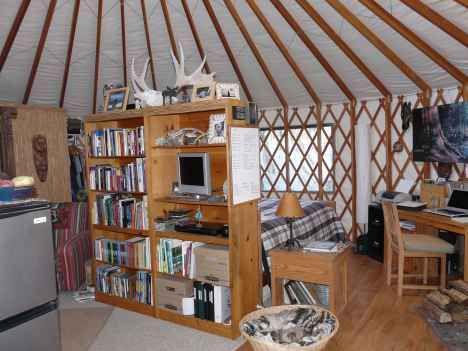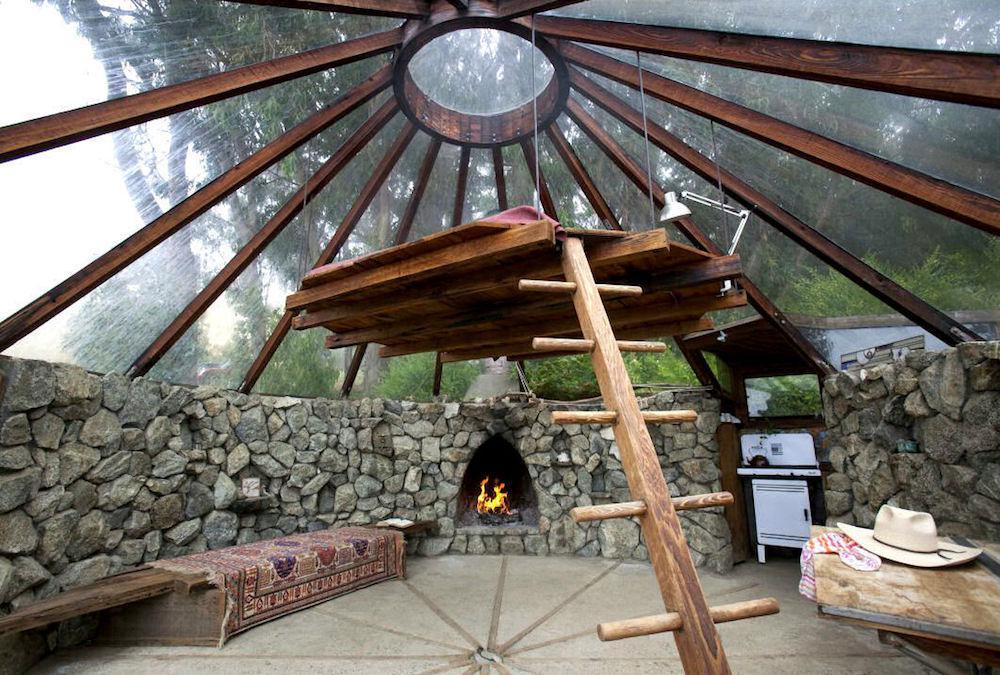The first image is the image on the left, the second image is the image on the right. Analyze the images presented: Is the assertion "A room with a fan-like ceiling contains an over-stuffed beige couch facing a fireplace with flame-glow in it." valid? Answer yes or no. No. 